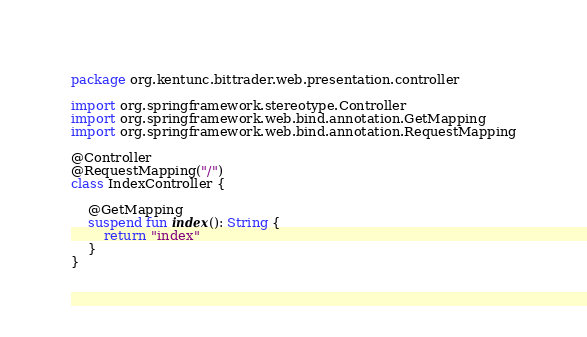Convert code to text. <code><loc_0><loc_0><loc_500><loc_500><_Kotlin_>package org.kentunc.bittrader.web.presentation.controller

import org.springframework.stereotype.Controller
import org.springframework.web.bind.annotation.GetMapping
import org.springframework.web.bind.annotation.RequestMapping

@Controller
@RequestMapping("/")
class IndexController {

    @GetMapping
    suspend fun index(): String {
        return "index"
    }
}
</code> 